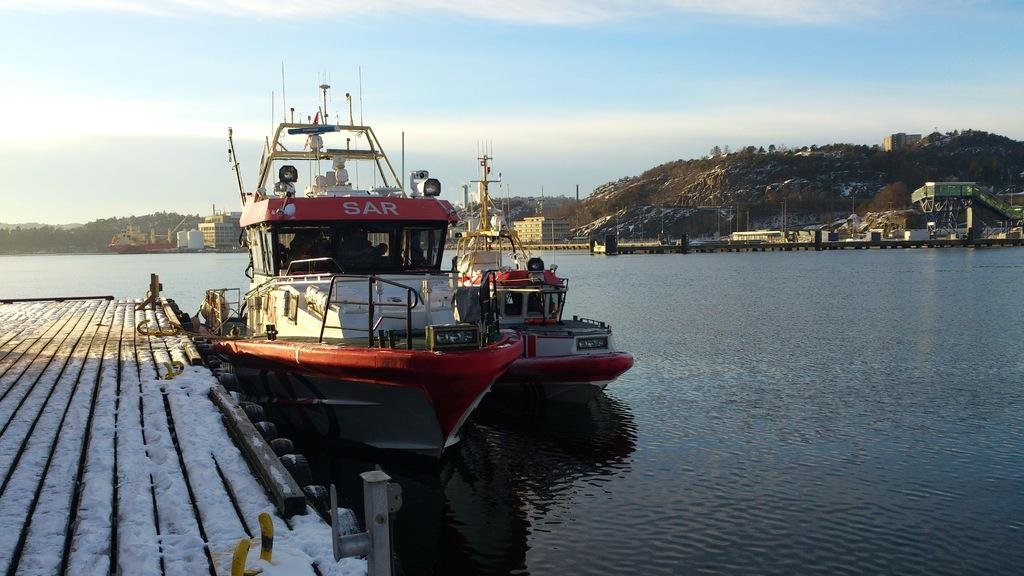Provide a one-sentence caption for the provided image. A red and white boat with eh word sar on the red top side of it. 